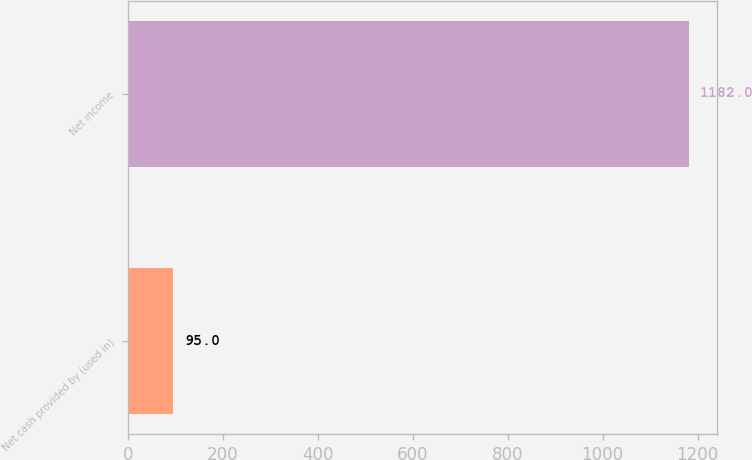<chart> <loc_0><loc_0><loc_500><loc_500><bar_chart><fcel>Net cash provided by (used in)<fcel>Net income<nl><fcel>95<fcel>1182<nl></chart> 